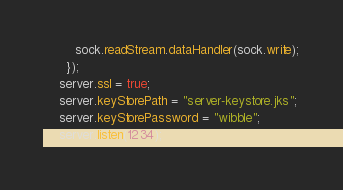<code> <loc_0><loc_0><loc_500><loc_500><_Ceylon_>        sock.readStream.dataHandler(sock.write);
      });
    server.ssl = true;
    server.keyStorePath = "server-keystore.jks";
    server.keyStorePassword = "wibble";
    server.listen(1234);</code> 